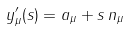<formula> <loc_0><loc_0><loc_500><loc_500>y _ { \mu } ^ { \prime } ( s ) = a _ { \mu } + s \, n _ { \mu }</formula> 